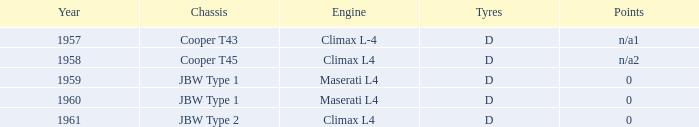What type of engine was available during 1961? Climax L4. Parse the table in full. {'header': ['Year', 'Chassis', 'Engine', 'Tyres', 'Points'], 'rows': [['1957', 'Cooper T43', 'Climax L-4', 'D', 'n/a1'], ['1958', 'Cooper T45', 'Climax L4', 'D', 'n/a2'], ['1959', 'JBW Type 1', 'Maserati L4', 'D', '0'], ['1960', 'JBW Type 1', 'Maserati L4', 'D', '0'], ['1961', 'JBW Type 2', 'Climax L4', 'D', '0']]} 